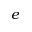Convert formula to latex. <formula><loc_0><loc_0><loc_500><loc_500>e</formula> 